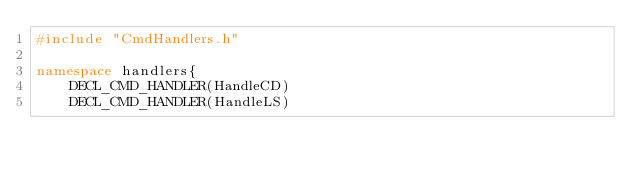Convert code to text. <code><loc_0><loc_0><loc_500><loc_500><_C++_>#include "CmdHandlers.h"

namespace handlers{
    DECL_CMD_HANDLER(HandleCD)
    DECL_CMD_HANDLER(HandleLS)</code> 